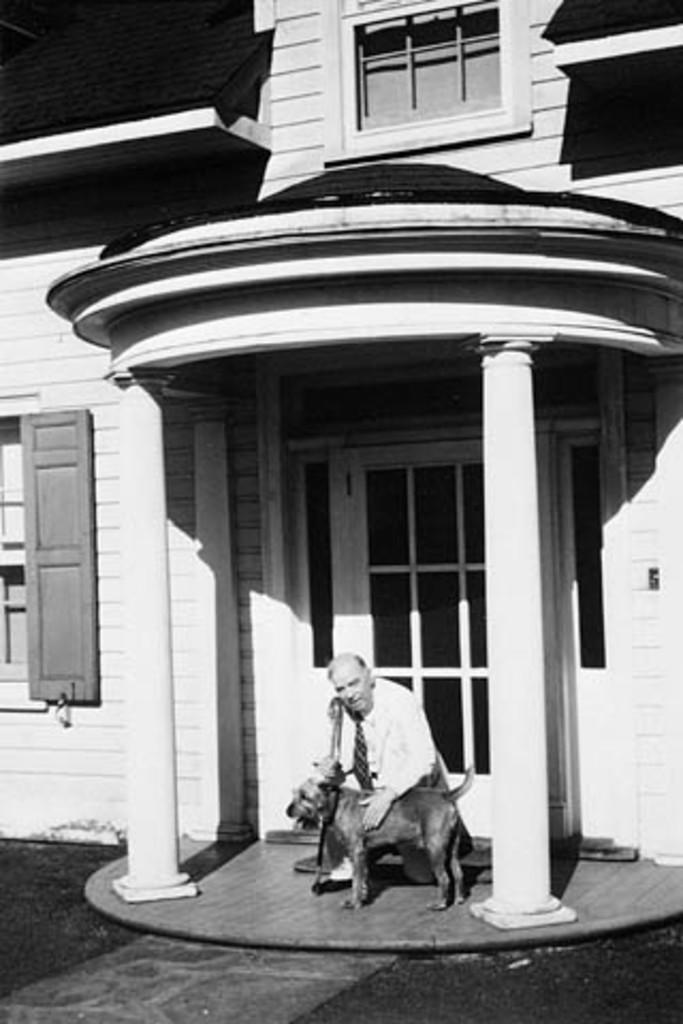In one or two sentences, can you explain what this image depicts? This is a black and white picture. On the background of the picture we can see a building. Here we can see one man in front of a dog. This is a window. This is a door. 